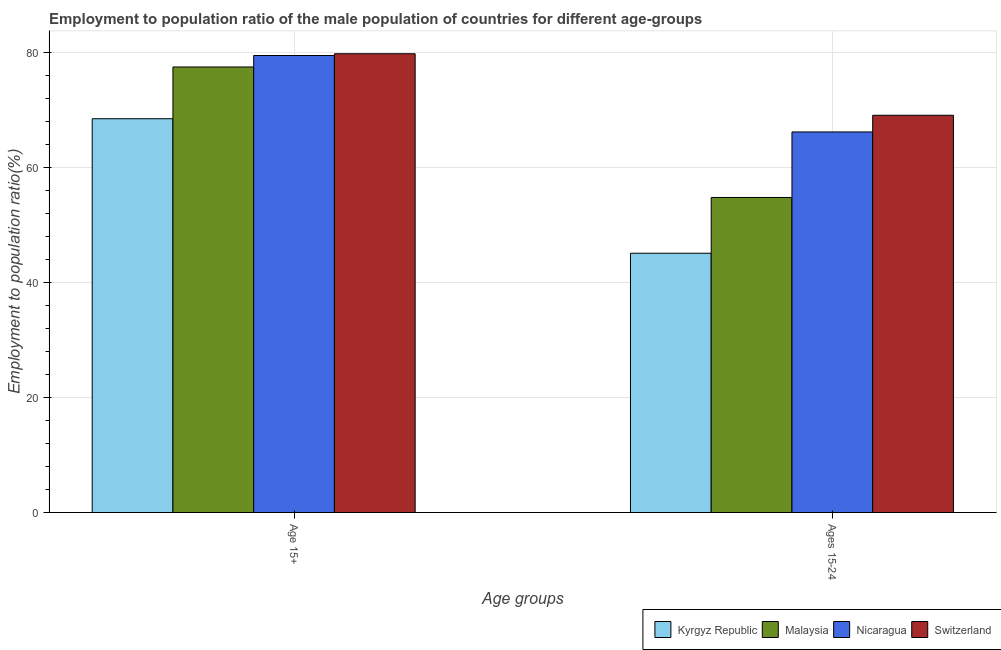Are the number of bars on each tick of the X-axis equal?
Provide a short and direct response. Yes. How many bars are there on the 1st tick from the left?
Offer a very short reply. 4. What is the label of the 2nd group of bars from the left?
Keep it short and to the point. Ages 15-24. What is the employment to population ratio(age 15-24) in Switzerland?
Provide a short and direct response. 69.1. Across all countries, what is the maximum employment to population ratio(age 15-24)?
Provide a succinct answer. 69.1. Across all countries, what is the minimum employment to population ratio(age 15+)?
Your answer should be compact. 68.5. In which country was the employment to population ratio(age 15+) maximum?
Offer a very short reply. Switzerland. In which country was the employment to population ratio(age 15+) minimum?
Ensure brevity in your answer.  Kyrgyz Republic. What is the total employment to population ratio(age 15+) in the graph?
Provide a succinct answer. 305.3. What is the difference between the employment to population ratio(age 15+) in Malaysia and that in Nicaragua?
Your answer should be very brief. -2. What is the difference between the employment to population ratio(age 15+) in Kyrgyz Republic and the employment to population ratio(age 15-24) in Switzerland?
Give a very brief answer. -0.6. What is the average employment to population ratio(age 15+) per country?
Keep it short and to the point. 76.33. What is the difference between the employment to population ratio(age 15-24) and employment to population ratio(age 15+) in Kyrgyz Republic?
Your response must be concise. -23.4. What is the ratio of the employment to population ratio(age 15+) in Malaysia to that in Kyrgyz Republic?
Provide a short and direct response. 1.13. In how many countries, is the employment to population ratio(age 15+) greater than the average employment to population ratio(age 15+) taken over all countries?
Keep it short and to the point. 3. What does the 2nd bar from the left in Age 15+ represents?
Ensure brevity in your answer.  Malaysia. What does the 2nd bar from the right in Age 15+ represents?
Provide a succinct answer. Nicaragua. How many bars are there?
Keep it short and to the point. 8. Are the values on the major ticks of Y-axis written in scientific E-notation?
Offer a terse response. No. Does the graph contain any zero values?
Your answer should be very brief. No. Does the graph contain grids?
Offer a terse response. Yes. Where does the legend appear in the graph?
Your answer should be very brief. Bottom right. How many legend labels are there?
Ensure brevity in your answer.  4. What is the title of the graph?
Provide a succinct answer. Employment to population ratio of the male population of countries for different age-groups. What is the label or title of the X-axis?
Ensure brevity in your answer.  Age groups. What is the label or title of the Y-axis?
Ensure brevity in your answer.  Employment to population ratio(%). What is the Employment to population ratio(%) of Kyrgyz Republic in Age 15+?
Keep it short and to the point. 68.5. What is the Employment to population ratio(%) in Malaysia in Age 15+?
Offer a very short reply. 77.5. What is the Employment to population ratio(%) in Nicaragua in Age 15+?
Ensure brevity in your answer.  79.5. What is the Employment to population ratio(%) in Switzerland in Age 15+?
Your answer should be compact. 79.8. What is the Employment to population ratio(%) in Kyrgyz Republic in Ages 15-24?
Provide a short and direct response. 45.1. What is the Employment to population ratio(%) of Malaysia in Ages 15-24?
Your answer should be very brief. 54.8. What is the Employment to population ratio(%) of Nicaragua in Ages 15-24?
Provide a succinct answer. 66.2. What is the Employment to population ratio(%) of Switzerland in Ages 15-24?
Keep it short and to the point. 69.1. Across all Age groups, what is the maximum Employment to population ratio(%) in Kyrgyz Republic?
Your response must be concise. 68.5. Across all Age groups, what is the maximum Employment to population ratio(%) in Malaysia?
Keep it short and to the point. 77.5. Across all Age groups, what is the maximum Employment to population ratio(%) in Nicaragua?
Your answer should be very brief. 79.5. Across all Age groups, what is the maximum Employment to population ratio(%) in Switzerland?
Give a very brief answer. 79.8. Across all Age groups, what is the minimum Employment to population ratio(%) of Kyrgyz Republic?
Your answer should be compact. 45.1. Across all Age groups, what is the minimum Employment to population ratio(%) in Malaysia?
Your answer should be very brief. 54.8. Across all Age groups, what is the minimum Employment to population ratio(%) in Nicaragua?
Make the answer very short. 66.2. Across all Age groups, what is the minimum Employment to population ratio(%) in Switzerland?
Offer a terse response. 69.1. What is the total Employment to population ratio(%) of Kyrgyz Republic in the graph?
Give a very brief answer. 113.6. What is the total Employment to population ratio(%) of Malaysia in the graph?
Give a very brief answer. 132.3. What is the total Employment to population ratio(%) in Nicaragua in the graph?
Your response must be concise. 145.7. What is the total Employment to population ratio(%) in Switzerland in the graph?
Your answer should be compact. 148.9. What is the difference between the Employment to population ratio(%) in Kyrgyz Republic in Age 15+ and that in Ages 15-24?
Offer a terse response. 23.4. What is the difference between the Employment to population ratio(%) in Malaysia in Age 15+ and that in Ages 15-24?
Ensure brevity in your answer.  22.7. What is the difference between the Employment to population ratio(%) of Nicaragua in Age 15+ and that in Ages 15-24?
Your response must be concise. 13.3. What is the difference between the Employment to population ratio(%) in Switzerland in Age 15+ and that in Ages 15-24?
Offer a terse response. 10.7. What is the average Employment to population ratio(%) of Kyrgyz Republic per Age groups?
Offer a very short reply. 56.8. What is the average Employment to population ratio(%) in Malaysia per Age groups?
Offer a terse response. 66.15. What is the average Employment to population ratio(%) of Nicaragua per Age groups?
Ensure brevity in your answer.  72.85. What is the average Employment to population ratio(%) in Switzerland per Age groups?
Give a very brief answer. 74.45. What is the difference between the Employment to population ratio(%) in Kyrgyz Republic and Employment to population ratio(%) in Malaysia in Age 15+?
Your answer should be very brief. -9. What is the difference between the Employment to population ratio(%) of Malaysia and Employment to population ratio(%) of Switzerland in Age 15+?
Your answer should be very brief. -2.3. What is the difference between the Employment to population ratio(%) of Nicaragua and Employment to population ratio(%) of Switzerland in Age 15+?
Offer a very short reply. -0.3. What is the difference between the Employment to population ratio(%) in Kyrgyz Republic and Employment to population ratio(%) in Nicaragua in Ages 15-24?
Your answer should be very brief. -21.1. What is the difference between the Employment to population ratio(%) of Kyrgyz Republic and Employment to population ratio(%) of Switzerland in Ages 15-24?
Provide a short and direct response. -24. What is the difference between the Employment to population ratio(%) in Malaysia and Employment to population ratio(%) in Nicaragua in Ages 15-24?
Your answer should be very brief. -11.4. What is the difference between the Employment to population ratio(%) in Malaysia and Employment to population ratio(%) in Switzerland in Ages 15-24?
Ensure brevity in your answer.  -14.3. What is the ratio of the Employment to population ratio(%) in Kyrgyz Republic in Age 15+ to that in Ages 15-24?
Offer a very short reply. 1.52. What is the ratio of the Employment to population ratio(%) in Malaysia in Age 15+ to that in Ages 15-24?
Your answer should be compact. 1.41. What is the ratio of the Employment to population ratio(%) in Nicaragua in Age 15+ to that in Ages 15-24?
Your answer should be very brief. 1.2. What is the ratio of the Employment to population ratio(%) of Switzerland in Age 15+ to that in Ages 15-24?
Ensure brevity in your answer.  1.15. What is the difference between the highest and the second highest Employment to population ratio(%) of Kyrgyz Republic?
Keep it short and to the point. 23.4. What is the difference between the highest and the second highest Employment to population ratio(%) in Malaysia?
Offer a terse response. 22.7. What is the difference between the highest and the second highest Employment to population ratio(%) of Nicaragua?
Provide a short and direct response. 13.3. What is the difference between the highest and the second highest Employment to population ratio(%) of Switzerland?
Your response must be concise. 10.7. What is the difference between the highest and the lowest Employment to population ratio(%) of Kyrgyz Republic?
Give a very brief answer. 23.4. What is the difference between the highest and the lowest Employment to population ratio(%) of Malaysia?
Your answer should be compact. 22.7. What is the difference between the highest and the lowest Employment to population ratio(%) in Switzerland?
Offer a very short reply. 10.7. 